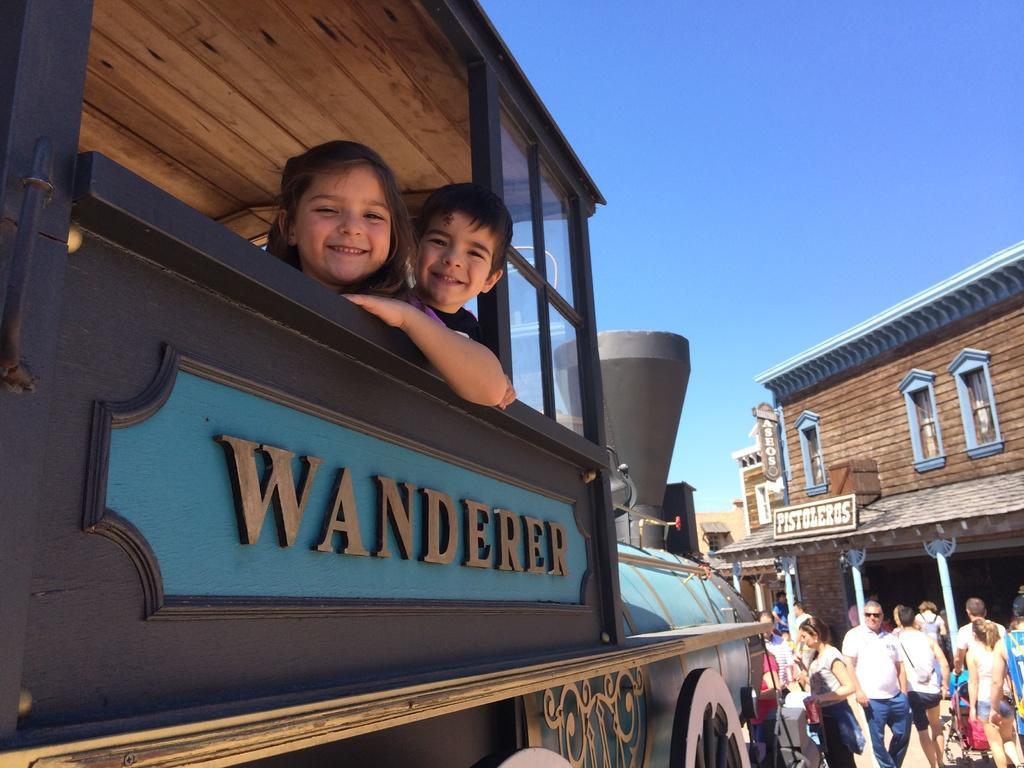Can you describe this image briefly? In this image I can see group of people. There is a vehicle and there are two children in it. Also there are buildings and there is sky. 